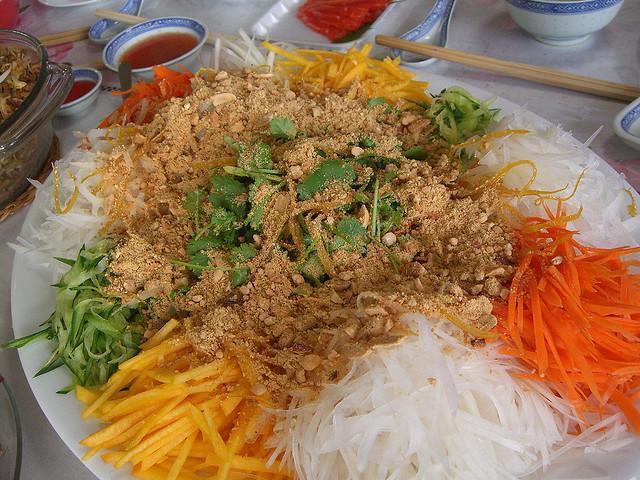How many bowls are there?
Give a very brief answer. 3. 